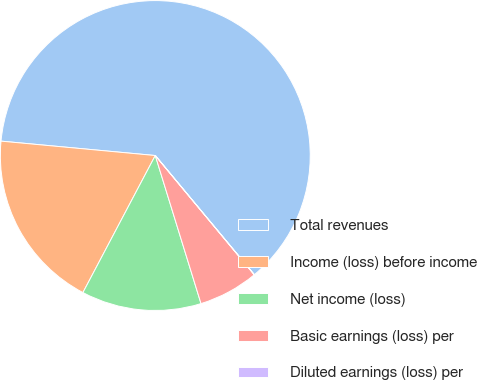Convert chart. <chart><loc_0><loc_0><loc_500><loc_500><pie_chart><fcel>Total revenues<fcel>Income (loss) before income<fcel>Net income (loss)<fcel>Basic earnings (loss) per<fcel>Diluted earnings (loss) per<nl><fcel>62.48%<fcel>18.75%<fcel>12.5%<fcel>6.26%<fcel>0.01%<nl></chart> 